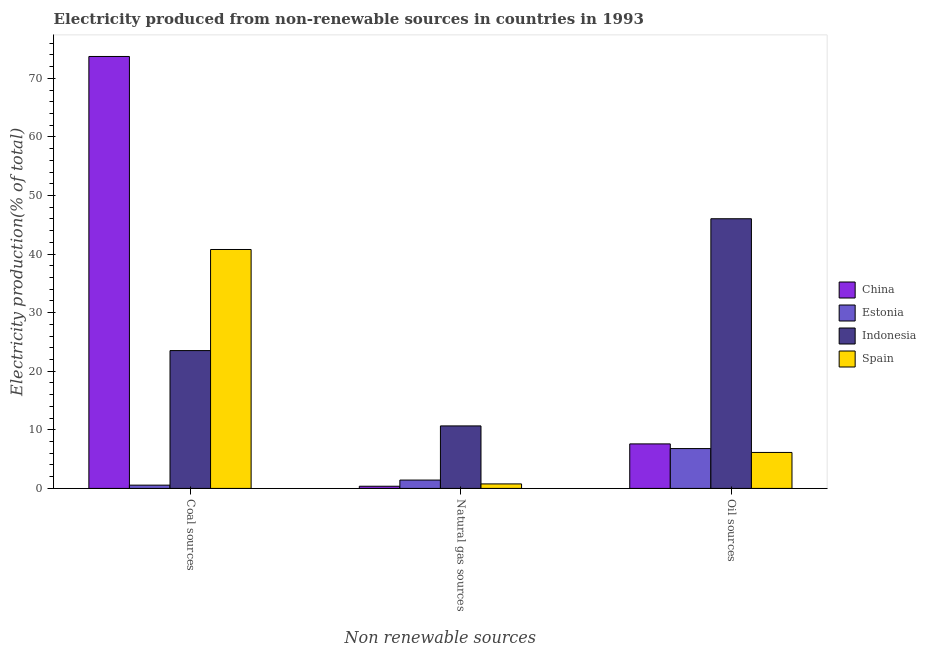What is the label of the 3rd group of bars from the left?
Make the answer very short. Oil sources. What is the percentage of electricity produced by oil sources in Estonia?
Keep it short and to the point. 6.8. Across all countries, what is the maximum percentage of electricity produced by coal?
Keep it short and to the point. 73.73. Across all countries, what is the minimum percentage of electricity produced by oil sources?
Your response must be concise. 6.14. In which country was the percentage of electricity produced by natural gas minimum?
Offer a terse response. China. What is the total percentage of electricity produced by oil sources in the graph?
Ensure brevity in your answer.  66.57. What is the difference between the percentage of electricity produced by coal in China and that in Estonia?
Make the answer very short. 73.17. What is the difference between the percentage of electricity produced by coal in Spain and the percentage of electricity produced by oil sources in Estonia?
Offer a terse response. 33.98. What is the average percentage of electricity produced by natural gas per country?
Provide a succinct answer. 3.31. What is the difference between the percentage of electricity produced by coal and percentage of electricity produced by natural gas in Indonesia?
Provide a short and direct response. 12.86. In how many countries, is the percentage of electricity produced by natural gas greater than 20 %?
Your response must be concise. 0. What is the ratio of the percentage of electricity produced by coal in Spain to that in Indonesia?
Your response must be concise. 1.73. Is the percentage of electricity produced by coal in Spain less than that in Indonesia?
Provide a short and direct response. No. Is the difference between the percentage of electricity produced by oil sources in Indonesia and Spain greater than the difference between the percentage of electricity produced by natural gas in Indonesia and Spain?
Ensure brevity in your answer.  Yes. What is the difference between the highest and the second highest percentage of electricity produced by oil sources?
Make the answer very short. 38.43. What is the difference between the highest and the lowest percentage of electricity produced by oil sources?
Make the answer very short. 39.89. In how many countries, is the percentage of electricity produced by coal greater than the average percentage of electricity produced by coal taken over all countries?
Provide a succinct answer. 2. Is it the case that in every country, the sum of the percentage of electricity produced by coal and percentage of electricity produced by natural gas is greater than the percentage of electricity produced by oil sources?
Ensure brevity in your answer.  No. How many bars are there?
Your answer should be compact. 12. Are all the bars in the graph horizontal?
Your answer should be very brief. No. Are the values on the major ticks of Y-axis written in scientific E-notation?
Provide a short and direct response. No. Does the graph contain any zero values?
Give a very brief answer. No. Where does the legend appear in the graph?
Keep it short and to the point. Center right. How are the legend labels stacked?
Offer a very short reply. Vertical. What is the title of the graph?
Provide a succinct answer. Electricity produced from non-renewable sources in countries in 1993. Does "Mauritius" appear as one of the legend labels in the graph?
Keep it short and to the point. No. What is the label or title of the X-axis?
Your answer should be compact. Non renewable sources. What is the Electricity production(% of total) in China in Coal sources?
Offer a very short reply. 73.73. What is the Electricity production(% of total) in Estonia in Coal sources?
Your answer should be very brief. 0.56. What is the Electricity production(% of total) of Indonesia in Coal sources?
Offer a very short reply. 23.53. What is the Electricity production(% of total) in Spain in Coal sources?
Your answer should be very brief. 40.78. What is the Electricity production(% of total) in China in Natural gas sources?
Your response must be concise. 0.37. What is the Electricity production(% of total) of Estonia in Natural gas sources?
Your answer should be compact. 1.43. What is the Electricity production(% of total) of Indonesia in Natural gas sources?
Offer a terse response. 10.67. What is the Electricity production(% of total) in Spain in Natural gas sources?
Ensure brevity in your answer.  0.77. What is the Electricity production(% of total) of China in Oil sources?
Your answer should be very brief. 7.6. What is the Electricity production(% of total) of Estonia in Oil sources?
Offer a very short reply. 6.8. What is the Electricity production(% of total) in Indonesia in Oil sources?
Your answer should be compact. 46.03. What is the Electricity production(% of total) in Spain in Oil sources?
Make the answer very short. 6.14. Across all Non renewable sources, what is the maximum Electricity production(% of total) in China?
Your answer should be compact. 73.73. Across all Non renewable sources, what is the maximum Electricity production(% of total) in Estonia?
Your response must be concise. 6.8. Across all Non renewable sources, what is the maximum Electricity production(% of total) of Indonesia?
Offer a very short reply. 46.03. Across all Non renewable sources, what is the maximum Electricity production(% of total) of Spain?
Make the answer very short. 40.78. Across all Non renewable sources, what is the minimum Electricity production(% of total) in China?
Provide a short and direct response. 0.37. Across all Non renewable sources, what is the minimum Electricity production(% of total) in Estonia?
Provide a succinct answer. 0.56. Across all Non renewable sources, what is the minimum Electricity production(% of total) of Indonesia?
Make the answer very short. 10.67. Across all Non renewable sources, what is the minimum Electricity production(% of total) in Spain?
Make the answer very short. 0.77. What is the total Electricity production(% of total) in China in the graph?
Your response must be concise. 81.69. What is the total Electricity production(% of total) of Estonia in the graph?
Offer a very short reply. 8.79. What is the total Electricity production(% of total) in Indonesia in the graph?
Make the answer very short. 80.22. What is the total Electricity production(% of total) of Spain in the graph?
Provide a short and direct response. 47.69. What is the difference between the Electricity production(% of total) of China in Coal sources and that in Natural gas sources?
Provide a short and direct response. 73.35. What is the difference between the Electricity production(% of total) in Estonia in Coal sources and that in Natural gas sources?
Your answer should be compact. -0.87. What is the difference between the Electricity production(% of total) of Indonesia in Coal sources and that in Natural gas sources?
Make the answer very short. 12.86. What is the difference between the Electricity production(% of total) in Spain in Coal sources and that in Natural gas sources?
Your response must be concise. 40.01. What is the difference between the Electricity production(% of total) in China in Coal sources and that in Oil sources?
Offer a very short reply. 66.13. What is the difference between the Electricity production(% of total) in Estonia in Coal sources and that in Oil sources?
Give a very brief answer. -6.24. What is the difference between the Electricity production(% of total) in Indonesia in Coal sources and that in Oil sources?
Ensure brevity in your answer.  -22.5. What is the difference between the Electricity production(% of total) in Spain in Coal sources and that in Oil sources?
Provide a short and direct response. 34.64. What is the difference between the Electricity production(% of total) of China in Natural gas sources and that in Oil sources?
Make the answer very short. -7.23. What is the difference between the Electricity production(% of total) in Estonia in Natural gas sources and that in Oil sources?
Give a very brief answer. -5.37. What is the difference between the Electricity production(% of total) in Indonesia in Natural gas sources and that in Oil sources?
Keep it short and to the point. -35.36. What is the difference between the Electricity production(% of total) of Spain in Natural gas sources and that in Oil sources?
Offer a very short reply. -5.37. What is the difference between the Electricity production(% of total) of China in Coal sources and the Electricity production(% of total) of Estonia in Natural gas sources?
Keep it short and to the point. 72.3. What is the difference between the Electricity production(% of total) of China in Coal sources and the Electricity production(% of total) of Indonesia in Natural gas sources?
Provide a short and direct response. 63.06. What is the difference between the Electricity production(% of total) of China in Coal sources and the Electricity production(% of total) of Spain in Natural gas sources?
Provide a short and direct response. 72.96. What is the difference between the Electricity production(% of total) of Estonia in Coal sources and the Electricity production(% of total) of Indonesia in Natural gas sources?
Keep it short and to the point. -10.11. What is the difference between the Electricity production(% of total) of Estonia in Coal sources and the Electricity production(% of total) of Spain in Natural gas sources?
Your response must be concise. -0.21. What is the difference between the Electricity production(% of total) in Indonesia in Coal sources and the Electricity production(% of total) in Spain in Natural gas sources?
Offer a very short reply. 22.76. What is the difference between the Electricity production(% of total) in China in Coal sources and the Electricity production(% of total) in Estonia in Oil sources?
Give a very brief answer. 66.92. What is the difference between the Electricity production(% of total) of China in Coal sources and the Electricity production(% of total) of Indonesia in Oil sources?
Offer a terse response. 27.7. What is the difference between the Electricity production(% of total) in China in Coal sources and the Electricity production(% of total) in Spain in Oil sources?
Keep it short and to the point. 67.59. What is the difference between the Electricity production(% of total) in Estonia in Coal sources and the Electricity production(% of total) in Indonesia in Oil sources?
Give a very brief answer. -45.47. What is the difference between the Electricity production(% of total) in Estonia in Coal sources and the Electricity production(% of total) in Spain in Oil sources?
Offer a terse response. -5.58. What is the difference between the Electricity production(% of total) of Indonesia in Coal sources and the Electricity production(% of total) of Spain in Oil sources?
Offer a very short reply. 17.39. What is the difference between the Electricity production(% of total) in China in Natural gas sources and the Electricity production(% of total) in Estonia in Oil sources?
Your response must be concise. -6.43. What is the difference between the Electricity production(% of total) in China in Natural gas sources and the Electricity production(% of total) in Indonesia in Oil sources?
Make the answer very short. -45.66. What is the difference between the Electricity production(% of total) in China in Natural gas sources and the Electricity production(% of total) in Spain in Oil sources?
Provide a succinct answer. -5.77. What is the difference between the Electricity production(% of total) of Estonia in Natural gas sources and the Electricity production(% of total) of Indonesia in Oil sources?
Make the answer very short. -44.6. What is the difference between the Electricity production(% of total) in Estonia in Natural gas sources and the Electricity production(% of total) in Spain in Oil sources?
Provide a succinct answer. -4.71. What is the difference between the Electricity production(% of total) of Indonesia in Natural gas sources and the Electricity production(% of total) of Spain in Oil sources?
Ensure brevity in your answer.  4.53. What is the average Electricity production(% of total) of China per Non renewable sources?
Your response must be concise. 27.23. What is the average Electricity production(% of total) of Estonia per Non renewable sources?
Offer a very short reply. 2.93. What is the average Electricity production(% of total) of Indonesia per Non renewable sources?
Your answer should be very brief. 26.74. What is the average Electricity production(% of total) of Spain per Non renewable sources?
Offer a very short reply. 15.9. What is the difference between the Electricity production(% of total) in China and Electricity production(% of total) in Estonia in Coal sources?
Make the answer very short. 73.17. What is the difference between the Electricity production(% of total) of China and Electricity production(% of total) of Indonesia in Coal sources?
Provide a succinct answer. 50.2. What is the difference between the Electricity production(% of total) of China and Electricity production(% of total) of Spain in Coal sources?
Provide a short and direct response. 32.95. What is the difference between the Electricity production(% of total) of Estonia and Electricity production(% of total) of Indonesia in Coal sources?
Give a very brief answer. -22.97. What is the difference between the Electricity production(% of total) of Estonia and Electricity production(% of total) of Spain in Coal sources?
Keep it short and to the point. -40.22. What is the difference between the Electricity production(% of total) of Indonesia and Electricity production(% of total) of Spain in Coal sources?
Provide a short and direct response. -17.25. What is the difference between the Electricity production(% of total) of China and Electricity production(% of total) of Estonia in Natural gas sources?
Your answer should be compact. -1.05. What is the difference between the Electricity production(% of total) of China and Electricity production(% of total) of Indonesia in Natural gas sources?
Your answer should be compact. -10.3. What is the difference between the Electricity production(% of total) in China and Electricity production(% of total) in Spain in Natural gas sources?
Provide a succinct answer. -0.4. What is the difference between the Electricity production(% of total) of Estonia and Electricity production(% of total) of Indonesia in Natural gas sources?
Provide a succinct answer. -9.24. What is the difference between the Electricity production(% of total) in Estonia and Electricity production(% of total) in Spain in Natural gas sources?
Provide a short and direct response. 0.66. What is the difference between the Electricity production(% of total) of Indonesia and Electricity production(% of total) of Spain in Natural gas sources?
Your response must be concise. 9.9. What is the difference between the Electricity production(% of total) in China and Electricity production(% of total) in Estonia in Oil sources?
Offer a terse response. 0.8. What is the difference between the Electricity production(% of total) in China and Electricity production(% of total) in Indonesia in Oil sources?
Your response must be concise. -38.43. What is the difference between the Electricity production(% of total) in China and Electricity production(% of total) in Spain in Oil sources?
Offer a very short reply. 1.46. What is the difference between the Electricity production(% of total) in Estonia and Electricity production(% of total) in Indonesia in Oil sources?
Provide a succinct answer. -39.23. What is the difference between the Electricity production(% of total) in Estonia and Electricity production(% of total) in Spain in Oil sources?
Offer a terse response. 0.66. What is the difference between the Electricity production(% of total) of Indonesia and Electricity production(% of total) of Spain in Oil sources?
Provide a succinct answer. 39.89. What is the ratio of the Electricity production(% of total) of China in Coal sources to that in Natural gas sources?
Give a very brief answer. 198.4. What is the ratio of the Electricity production(% of total) in Estonia in Coal sources to that in Natural gas sources?
Provide a short and direct response. 0.39. What is the ratio of the Electricity production(% of total) of Indonesia in Coal sources to that in Natural gas sources?
Give a very brief answer. 2.21. What is the ratio of the Electricity production(% of total) of China in Coal sources to that in Oil sources?
Your answer should be compact. 9.7. What is the ratio of the Electricity production(% of total) in Estonia in Coal sources to that in Oil sources?
Provide a short and direct response. 0.08. What is the ratio of the Electricity production(% of total) in Indonesia in Coal sources to that in Oil sources?
Make the answer very short. 0.51. What is the ratio of the Electricity production(% of total) of Spain in Coal sources to that in Oil sources?
Ensure brevity in your answer.  6.64. What is the ratio of the Electricity production(% of total) of China in Natural gas sources to that in Oil sources?
Provide a short and direct response. 0.05. What is the ratio of the Electricity production(% of total) of Estonia in Natural gas sources to that in Oil sources?
Your answer should be very brief. 0.21. What is the ratio of the Electricity production(% of total) of Indonesia in Natural gas sources to that in Oil sources?
Your answer should be very brief. 0.23. What is the ratio of the Electricity production(% of total) of Spain in Natural gas sources to that in Oil sources?
Your answer should be compact. 0.13. What is the difference between the highest and the second highest Electricity production(% of total) of China?
Make the answer very short. 66.13. What is the difference between the highest and the second highest Electricity production(% of total) of Estonia?
Provide a short and direct response. 5.37. What is the difference between the highest and the second highest Electricity production(% of total) in Indonesia?
Your answer should be very brief. 22.5. What is the difference between the highest and the second highest Electricity production(% of total) in Spain?
Provide a short and direct response. 34.64. What is the difference between the highest and the lowest Electricity production(% of total) of China?
Your response must be concise. 73.35. What is the difference between the highest and the lowest Electricity production(% of total) of Estonia?
Give a very brief answer. 6.24. What is the difference between the highest and the lowest Electricity production(% of total) of Indonesia?
Offer a very short reply. 35.36. What is the difference between the highest and the lowest Electricity production(% of total) of Spain?
Ensure brevity in your answer.  40.01. 